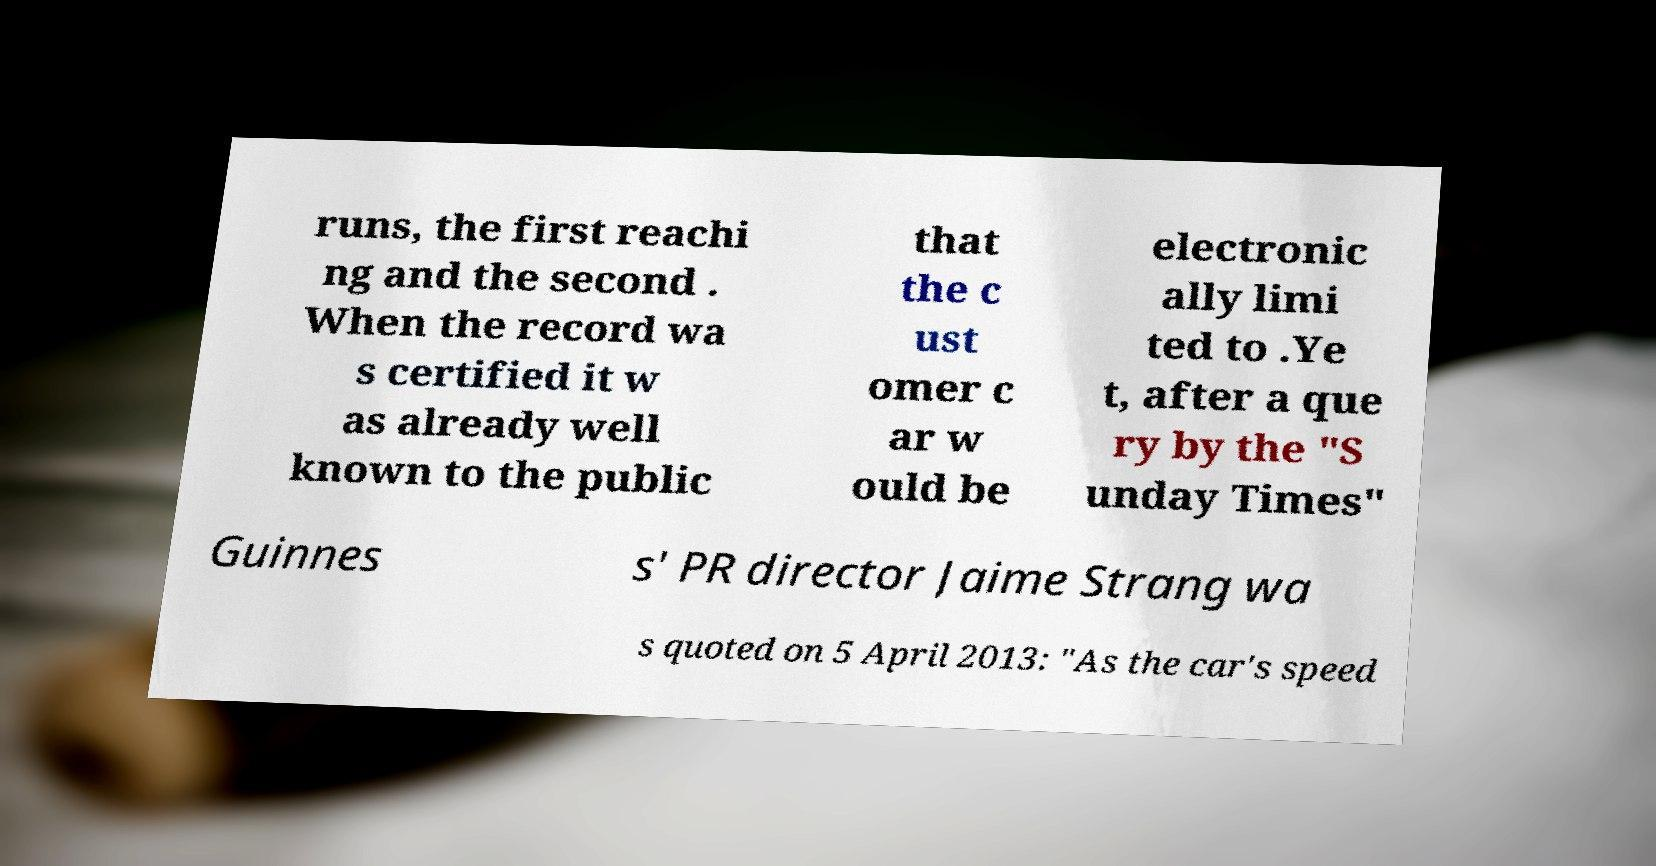I need the written content from this picture converted into text. Can you do that? runs, the first reachi ng and the second . When the record wa s certified it w as already well known to the public that the c ust omer c ar w ould be electronic ally limi ted to .Ye t, after a que ry by the "S unday Times" Guinnes s' PR director Jaime Strang wa s quoted on 5 April 2013: "As the car's speed 